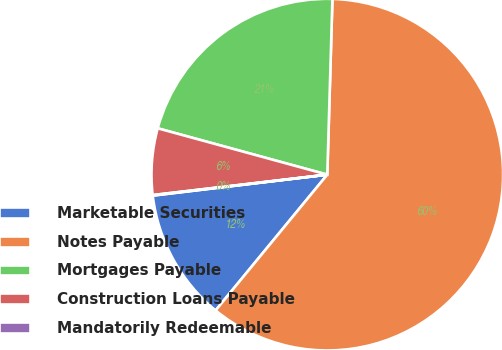Convert chart. <chart><loc_0><loc_0><loc_500><loc_500><pie_chart><fcel>Marketable Securities<fcel>Notes Payable<fcel>Mortgages Payable<fcel>Construction Loans Payable<fcel>Mandatorily Redeemable<nl><fcel>12.14%<fcel>60.49%<fcel>21.22%<fcel>6.1%<fcel>0.05%<nl></chart> 